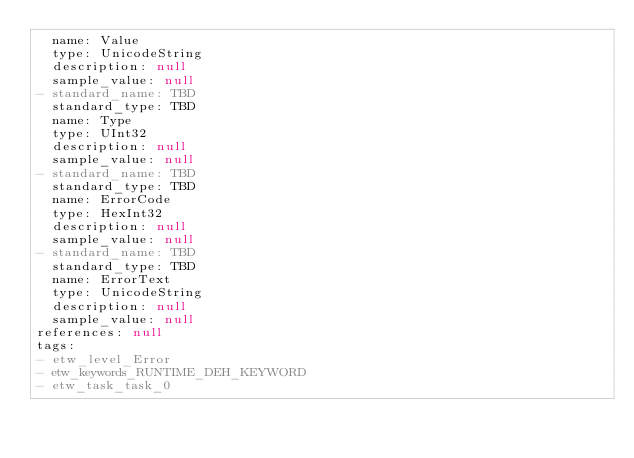<code> <loc_0><loc_0><loc_500><loc_500><_YAML_>  name: Value
  type: UnicodeString
  description: null
  sample_value: null
- standard_name: TBD
  standard_type: TBD
  name: Type
  type: UInt32
  description: null
  sample_value: null
- standard_name: TBD
  standard_type: TBD
  name: ErrorCode
  type: HexInt32
  description: null
  sample_value: null
- standard_name: TBD
  standard_type: TBD
  name: ErrorText
  type: UnicodeString
  description: null
  sample_value: null
references: null
tags:
- etw_level_Error
- etw_keywords_RUNTIME_DEH_KEYWORD
- etw_task_task_0
</code> 